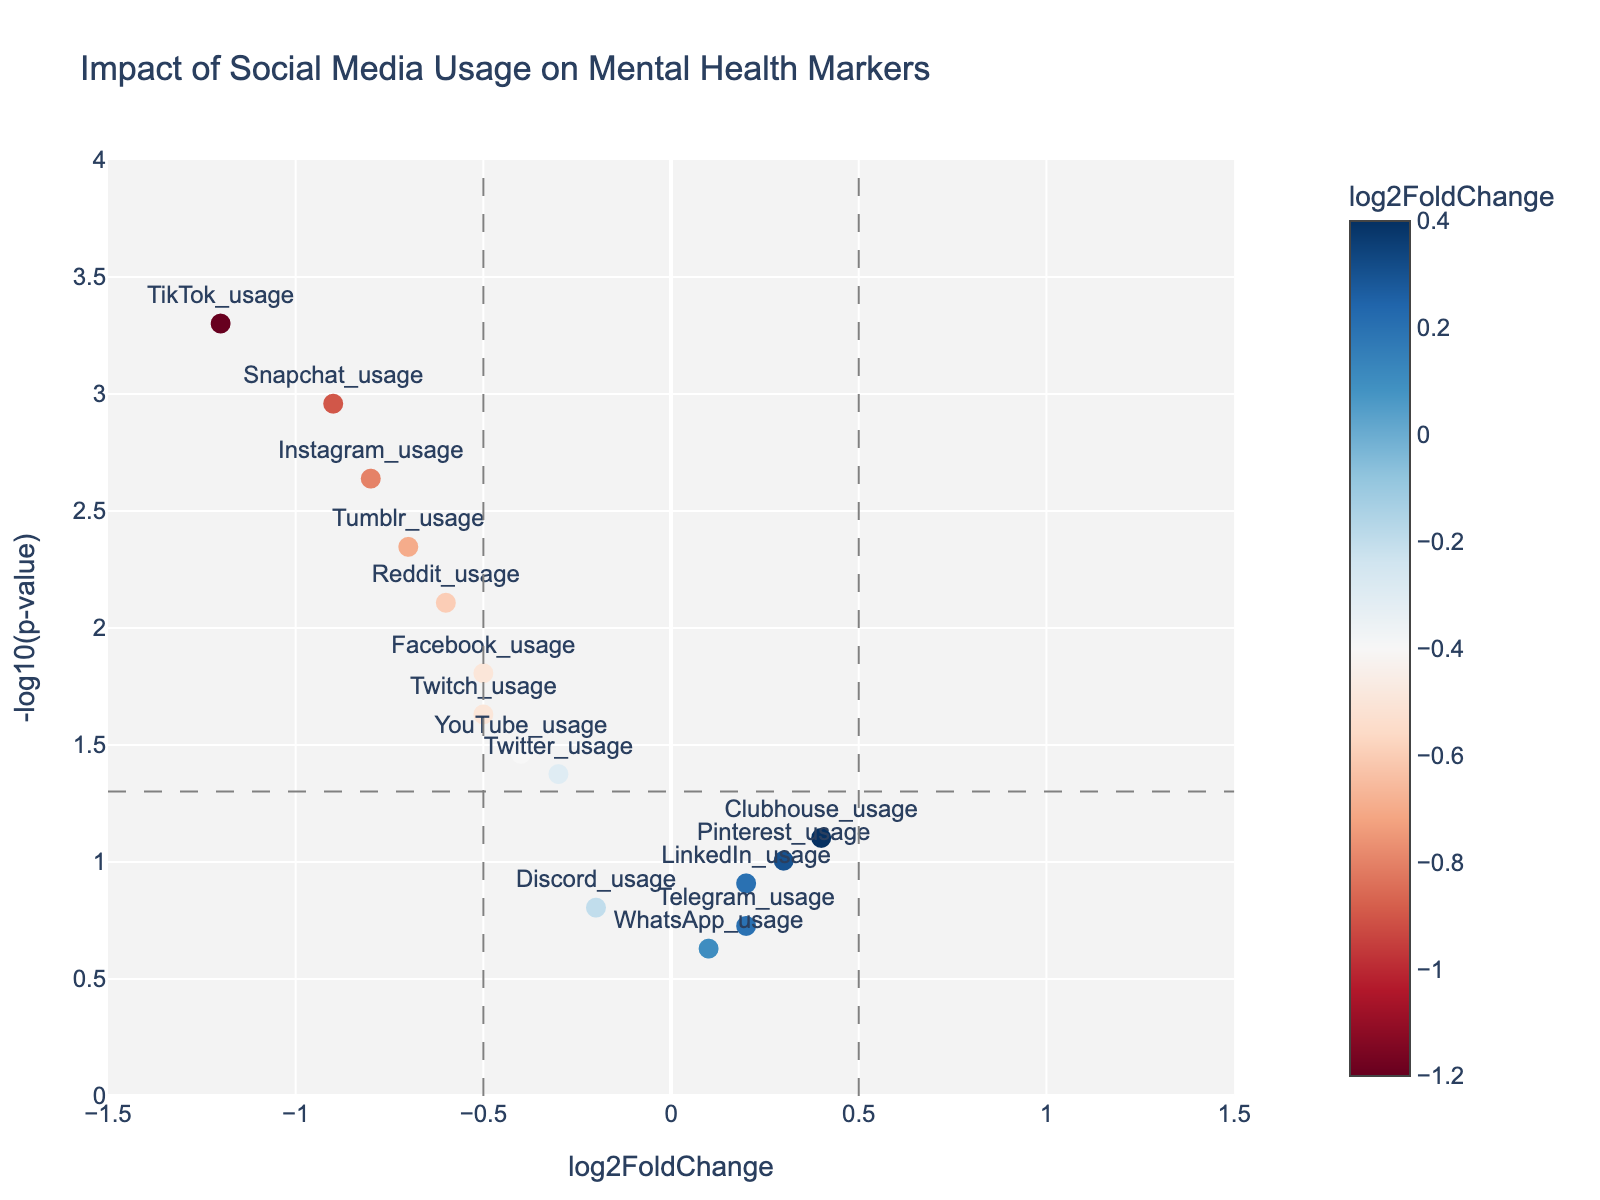what's the title of the figure? The title appears at the top of the figure, providing a summary of what the plot represents. In this case, it describes the content and context of the figure.
Answer: Impact of Social Media Usage on Mental Health Markers how many social media platforms are represented in the plot? Each marker in the plot represents a social media platform, and there are text labels for each marker. Count the total number of labels to find the answer.
Answer: 15 which social media platform has the highest -log10(p-value)? The -log10(p-value) decreases as the y-axis value increases. The platform corresponding to the highest y-axis value in the plot has the highest -log10(p-value).
Answer: TikTok_usage are any platforms associated with positive log2FoldChange? Positive log2FoldChange is represented by markers to the right of the vertical zero line. Identify platforms placed on this side of the plot.
Answer: LinkedIn_usage, Pinterest_usage, Clubhouse_usage, Telegram_usage, WhatsApp_usage which platforms have a p-value less than 0.05 and a negative log2FoldChange? A p-value less than 0.05 corresponds to a -log10(p-value) above the horizontal threshold line. Negative log2FoldChange is represented by markers to the left of the vertical zero line. Identify platforms meeting both criteria.
Answer: Instagram_usage, Facebook_usage, Twitter_usage, TikTok_usage, Reddit_usage, Snapchat_usage, Tumblr_usage, YouTube_usage, Twitch_usage which platform has the highest negative log2FoldChange? The log2FoldChange is plotted on the x-axis. The platform with the smallest x-axis value (furthest to the left) has the highest negative log2FoldChange.
Answer: TikTok_usage what is the log2FoldChange value for YouTube_usage? Locate the YouTube_usage marker in the plot and read its corresponding log2FoldChange on the x-axis.
Answer: -0.4 compare Instagram_usage and Snapchat_usage in terms of log2FoldChange and p-value Examine the positions of both markers for Instagram_usage and Snapchat_usage on both x and y axes to compare their log2FoldChange and p-value. Instagram_usage has a slightly higher x-axis value (-0.8 compared to -0.9) and a higher y-axis value (2.3 compared to 3.0).
Answer: Instagram_usage has a higher log2FoldChange and a higher p-value than Snapchat_usage what does the horizontal grey dashed line represent? The plot includes specific lines to help interpret data; the horizontal grey dashed line typically indicates a significance threshold for the p-value.
Answer: The significance threshold for p-value (0.05) does the plot suggest any usage patterns more likely to negatively impact mental health? Negative log2FoldChange suggests a possible negative impact. Platforms further left on the x-axis with significant -log10(p-values) (above the threshold line) may indicate stronger negative impacts on mental health.
Answer: Platforms such as TikTok, Snapchat, Instagram appear more likely to negatively impact mental health 